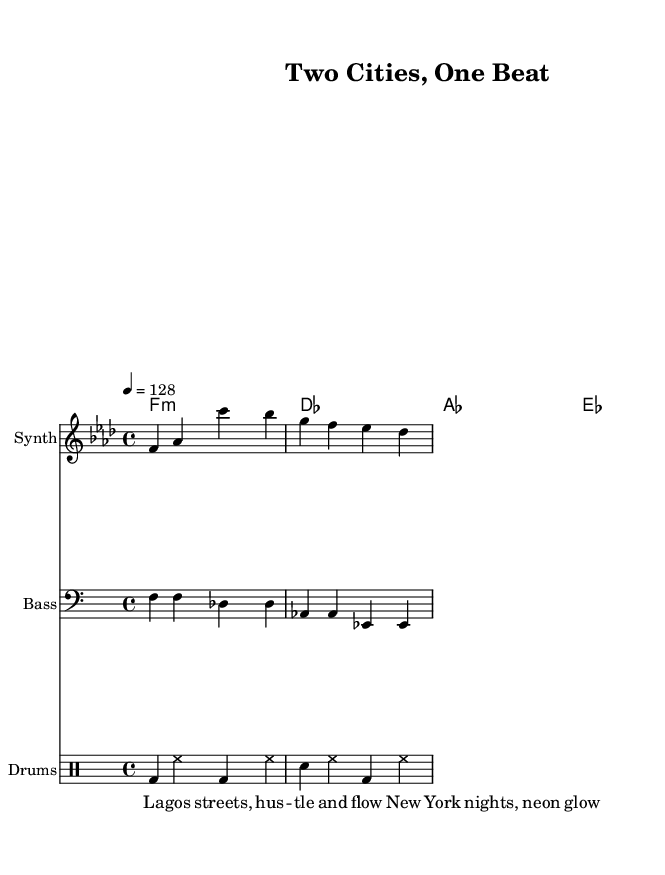What is the key signature of this music? The key signature is F minor, which has four flats (B flat, E flat, A flat, and D flat) indicated at the beginning of the staff.
Answer: F minor What is the time signature of this piece? The time signature is 4/4, which can be identified in the beginning of the piece where it indicates four beats per measure and a quarter note gets one beat.
Answer: 4/4 What is the tempo marking for the music? The tempo marking is 128 beats per minute, noted in the score as "4 = 128," indicating that the quarter note is played at this speed.
Answer: 128 How many bars are present in the melody section? The melody consists of two bars, as counted by identifying the measures from the beginning to the end based on the notation and the placement of the vertical lines.
Answer: 2 What type of musical performance does the score include for drums? The score includes a standard pattern indicated in the drum staff, which incorporates bass drum, snare, and hi-hat; this is characteristic of the composition style in house music.
Answer: Patterns What elements signify that this is a Tech House track? The presence of a steady four-on-the-floor beat, a repetitive groove, and the incorporation of electronic instruments (like synth and bass) are all defining aspects of Tech House, evident in the structure of this piece.
Answer: Electronic elements Which cities are referenced in the lyrics, and what do they represent? The lyrics reference "Lagos" and "New York," representing the urban lifestyles and cultural contrasts between the two cities, particularly their nightlife and economic hustle.
Answer: Lagos and New York 